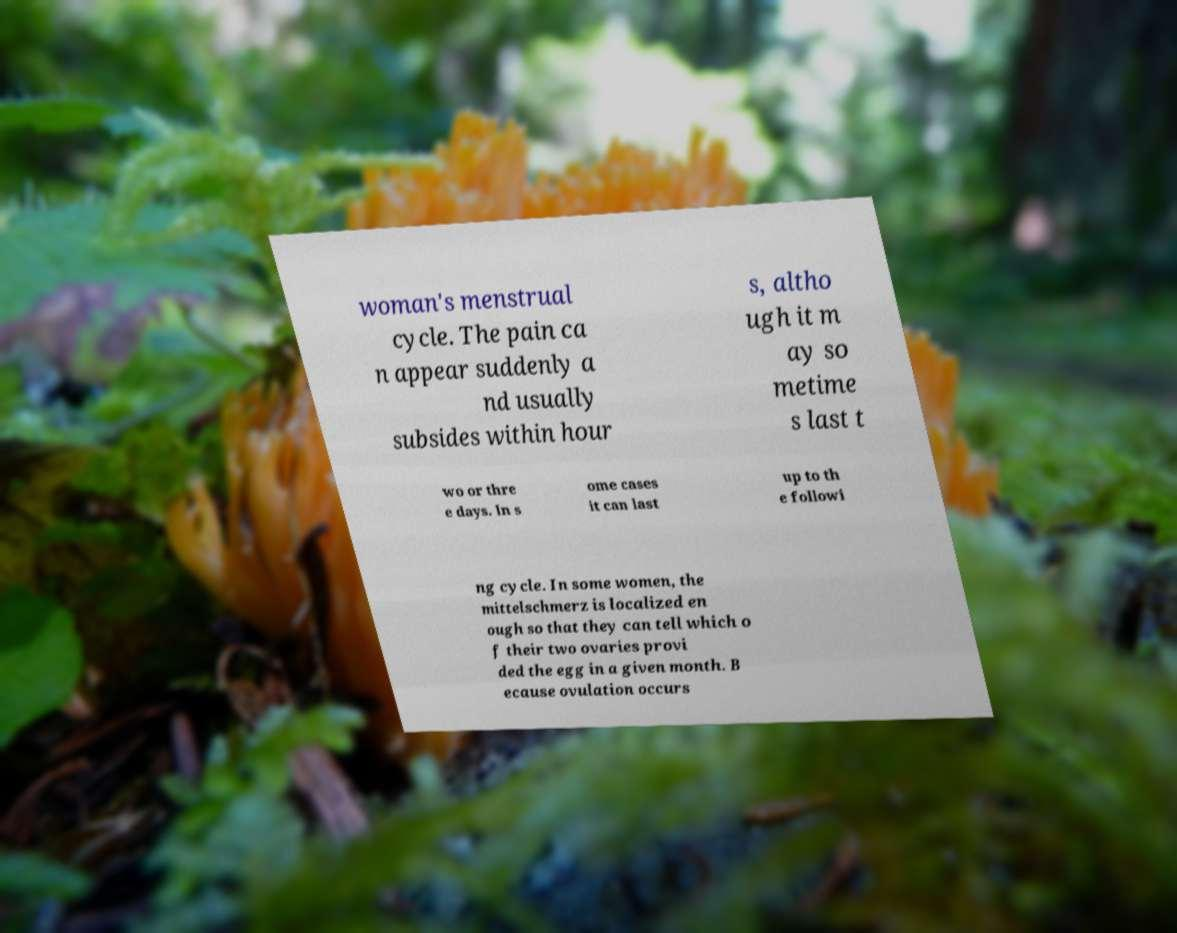Could you extract and type out the text from this image? woman's menstrual cycle. The pain ca n appear suddenly a nd usually subsides within hour s, altho ugh it m ay so metime s last t wo or thre e days. In s ome cases it can last up to th e followi ng cycle. In some women, the mittelschmerz is localized en ough so that they can tell which o f their two ovaries provi ded the egg in a given month. B ecause ovulation occurs 